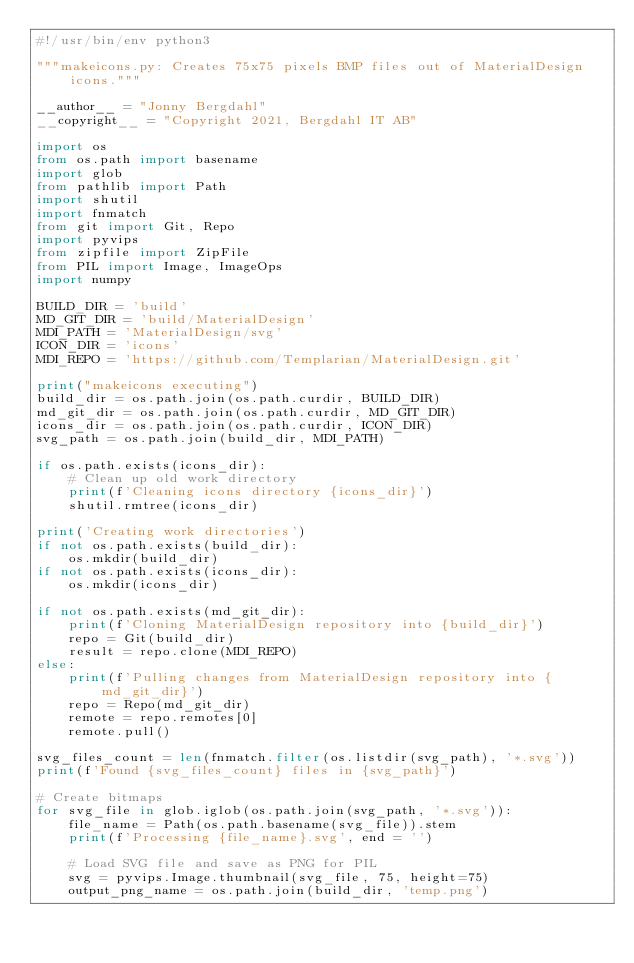Convert code to text. <code><loc_0><loc_0><loc_500><loc_500><_Python_>#!/usr/bin/env python3

"""makeicons.py: Creates 75x75 pixels BMP files out of MaterialDesign icons."""

__author__ = "Jonny Bergdahl"
__copyright__ = "Copyright 2021, Bergdahl IT AB"

import os
from os.path import basename
import glob
from pathlib import Path
import shutil
import fnmatch
from git import Git, Repo
import pyvips
from zipfile import ZipFile
from PIL import Image, ImageOps
import numpy

BUILD_DIR = 'build'
MD_GIT_DIR = 'build/MaterialDesign'
MDI_PATH = 'MaterialDesign/svg'
ICON_DIR = 'icons'
MDI_REPO = 'https://github.com/Templarian/MaterialDesign.git'

print("makeicons executing")
build_dir = os.path.join(os.path.curdir, BUILD_DIR)
md_git_dir = os.path.join(os.path.curdir, MD_GIT_DIR)
icons_dir = os.path.join(os.path.curdir, ICON_DIR)
svg_path = os.path.join(build_dir, MDI_PATH)

if os.path.exists(icons_dir):
    # Clean up old work directory
    print(f'Cleaning icons directory {icons_dir}')
    shutil.rmtree(icons_dir)

print('Creating work directories')
if not os.path.exists(build_dir):
    os.mkdir(build_dir)
if not os.path.exists(icons_dir):
    os.mkdir(icons_dir)

if not os.path.exists(md_git_dir):
    print(f'Cloning MaterialDesign repository into {build_dir}')
    repo = Git(build_dir)
    result = repo.clone(MDI_REPO)
else:
    print(f'Pulling changes from MaterialDesign repository into {md_git_dir}')
    repo = Repo(md_git_dir)
    remote = repo.remotes[0]
    remote.pull()

svg_files_count = len(fnmatch.filter(os.listdir(svg_path), '*.svg'))
print(f'Found {svg_files_count} files in {svg_path}')

# Create bitmaps
for svg_file in glob.iglob(os.path.join(svg_path, '*.svg')):
    file_name = Path(os.path.basename(svg_file)).stem
    print(f'Processing {file_name}.svg', end = '')

    # Load SVG file and save as PNG for PIL
    svg = pyvips.Image.thumbnail(svg_file, 75, height=75)
    output_png_name = os.path.join(build_dir, 'temp.png')</code> 